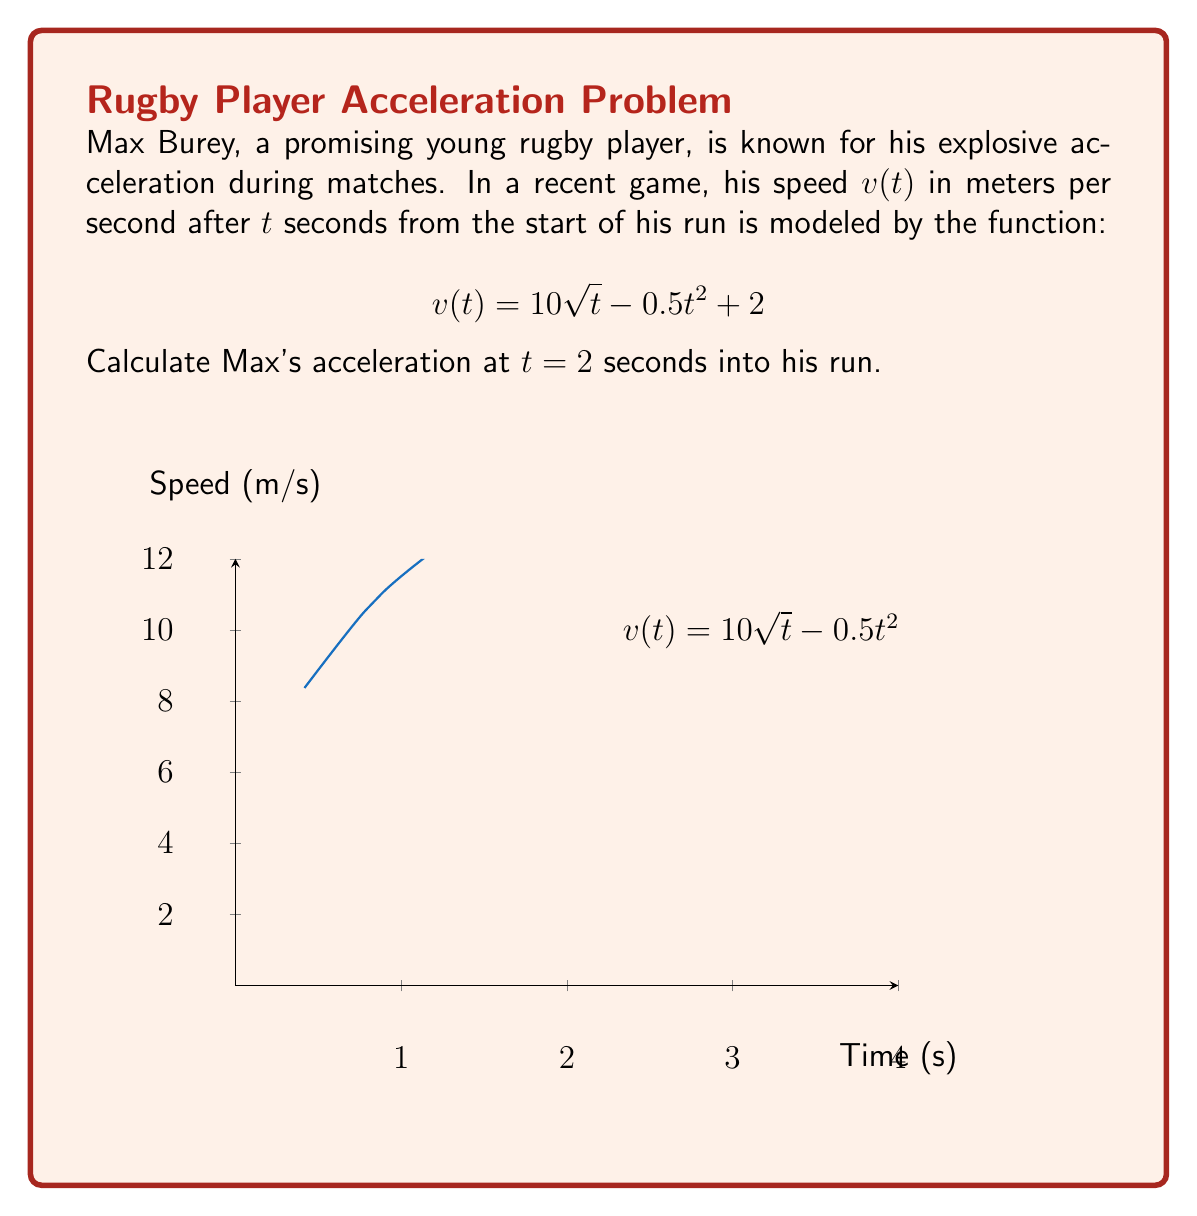Solve this math problem. To find Max's acceleration at $t = 2$ seconds, we need to calculate the derivative of the speed function $v(t)$ and then evaluate it at $t = 2$. Here's the step-by-step process:

1) The speed function is given as:
   $$v(t) = 10\sqrt{t} - 0.5t^2 + 2$$

2) To find acceleration, we need to differentiate $v(t)$ with respect to $t$:
   $$a(t) = \frac{dv}{dt} = \frac{d}{dt}(10\sqrt{t} - 0.5t^2 + 2)$$

3) Using the power rule and the chain rule:
   $$a(t) = 10 \cdot \frac{1}{2\sqrt{t}} - 2t + 0$$

4) Simplifying:
   $$a(t) = \frac{5}{\sqrt{t}} - 2t$$

5) Now, we evaluate $a(t)$ at $t = 2$:
   $$a(2) = \frac{5}{\sqrt{2}} - 2(2)$$

6) Simplifying:
   $$a(2) = \frac{5}{\sqrt{2}} - 4 \approx -0.47$$

Therefore, Max's acceleration at $t = 2$ seconds is approximately -0.47 m/s².
Answer: $-0.47$ m/s² 